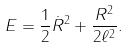<formula> <loc_0><loc_0><loc_500><loc_500>E = \frac { 1 } { 2 } \dot { R } ^ { 2 } + \frac { R ^ { 2 } } { 2 \ell ^ { 2 } } .</formula> 